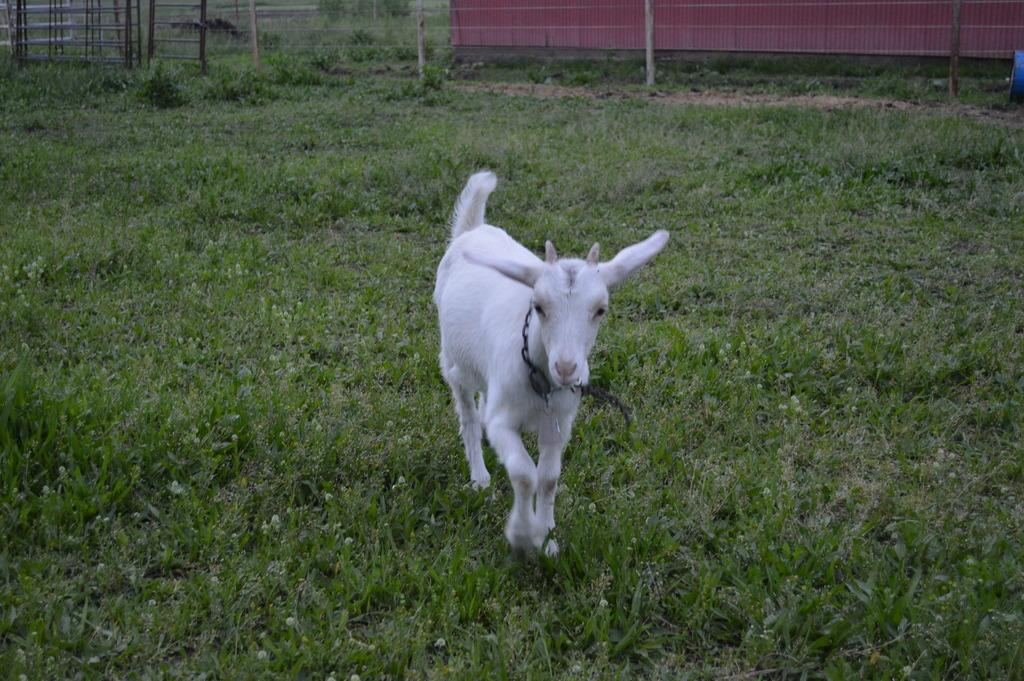What animal is on the ground in the image? There is a goat on the ground in the image. What type of vegetation can be seen in the image? There are plants visible in the image. What type of barrier is present in the image? There is a fence in the image. What type of material is used for the poles in the image? Metal poles and wooden poles are visible in the image. What type of structure is present in the image? There is a house with a roof in the image. What type of harmony is being played by the goat in the image? There is no indication of music or harmony in the image; it features a goat on the ground, plants, a fence, poles, and a house. 